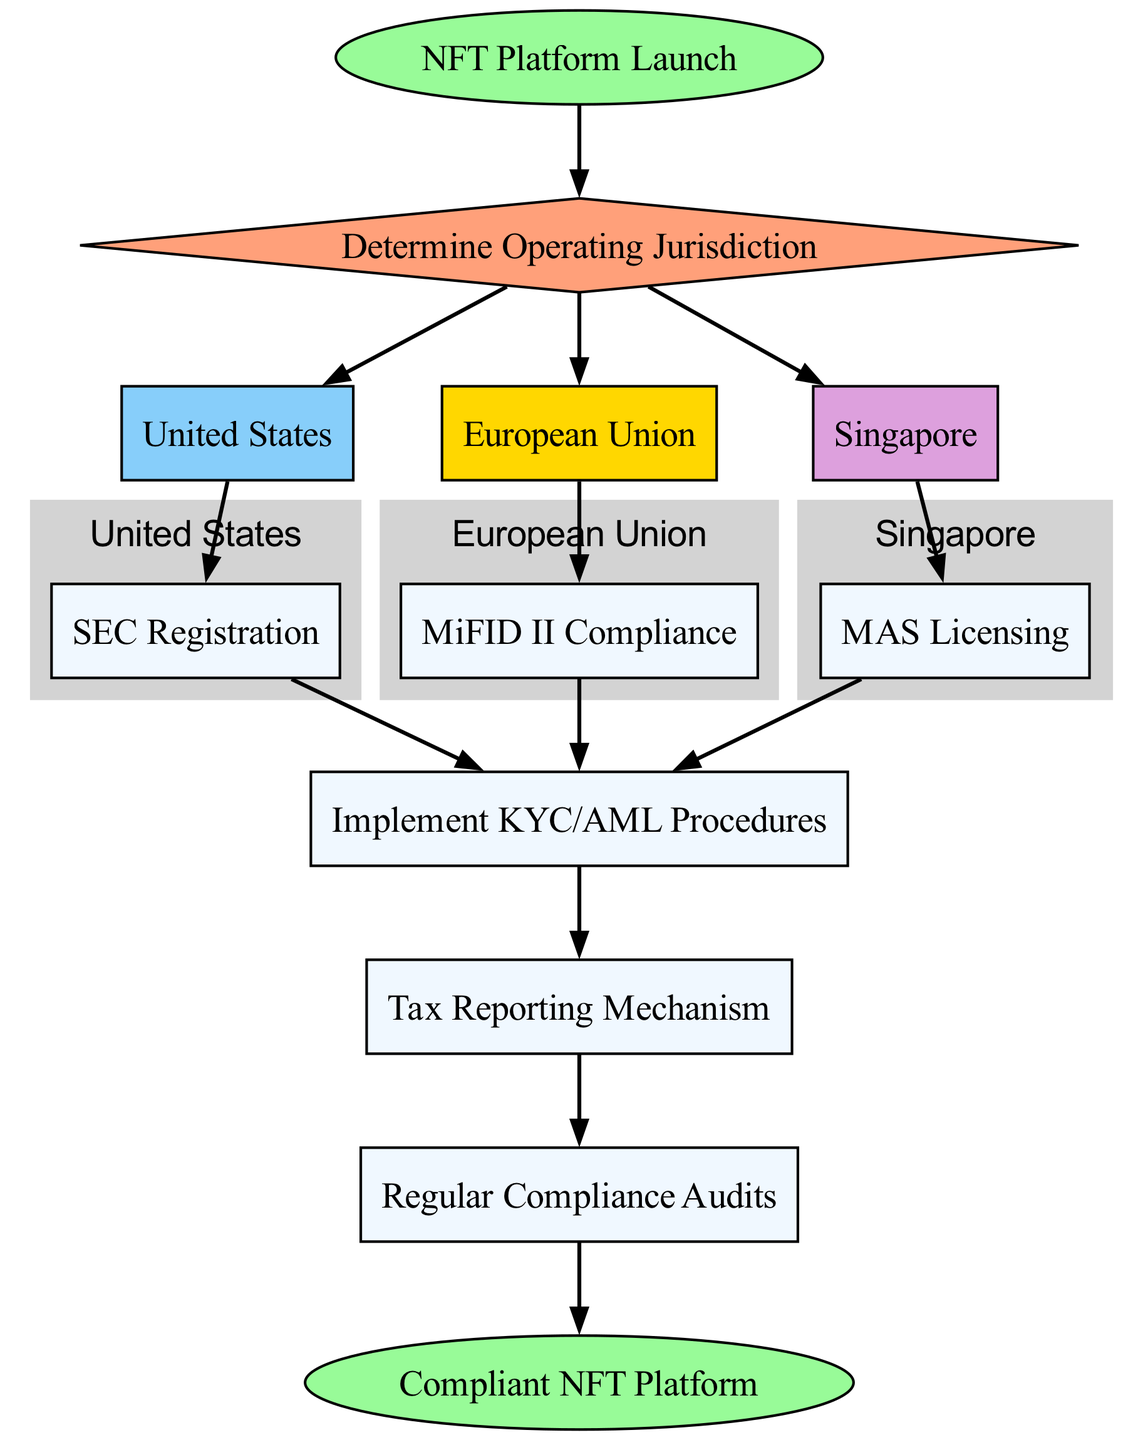What is the first step for launching an NFT platform? The first step in the flowchart is labeled "NFT Platform Launch," indicating that this is the initial action before any further regulatory processes take place.
Answer: NFT Platform Launch How many jurisdictions are considered in this flowchart? The flowchart includes three jurisdictions: the United States, the European Union, and Singapore. Each jurisdiction has its own regulatory requirements as depicted in the nodes.
Answer: Three Which regulatory requirement follows the SEC registration in the United States? In the United States, after the "SEC Registration" node, the next step is to "Implement KYC/AML Procedures." This indicates the need for Know Your Customer and Anti-Money Laundering measures after SEC compliance.
Answer: Implement KYC/AML Procedures What is required after tax reporting in the compliance flow? After the "Tax Reporting Mechanism," the next step in the flowchart is "Regular Compliance Audits," indicating that audits are necessary to ensure ongoing compliance after tax reporting.
Answer: Regular Compliance Audits What are the three jurisdictions represented in the flowchart? The flowchart represents the United States, European Union, and Singapore as the main jurisdictions where NFT platforms may operate, each with distinct regulatory requirements.
Answer: United States, European Union, Singapore Which compliance measure is common across all jurisdictions? The "Implement KYC/AML Procedures" node is a common requirement across the United States, European Union, and Singapore, showing that all jurisdictions emphasize customer identification and anti-money laundering practices.
Answer: Implement KYC/AML Procedures How many edges are present in the flowchart? Counting the directed edges in the diagram, there are a total of twelve edges indicating the various paths and connections made in the compliance process of the NFT platform across different jurisdictions.
Answer: Twelve What color represents the nodes of the jurisdictions? The jurisdiction nodes are represented by the color light grey according to the diagram's subgraph specifications. This emphasizes their grouping and importance in the flowchart.
Answer: Light grey What does the node labeled "end" signify in the flowchart? The "end" node signifies the completion of the compliance process, indicating that by following all the necessary steps, the NFT platform achieves compliance status.
Answer: Compliant NFT Platform 